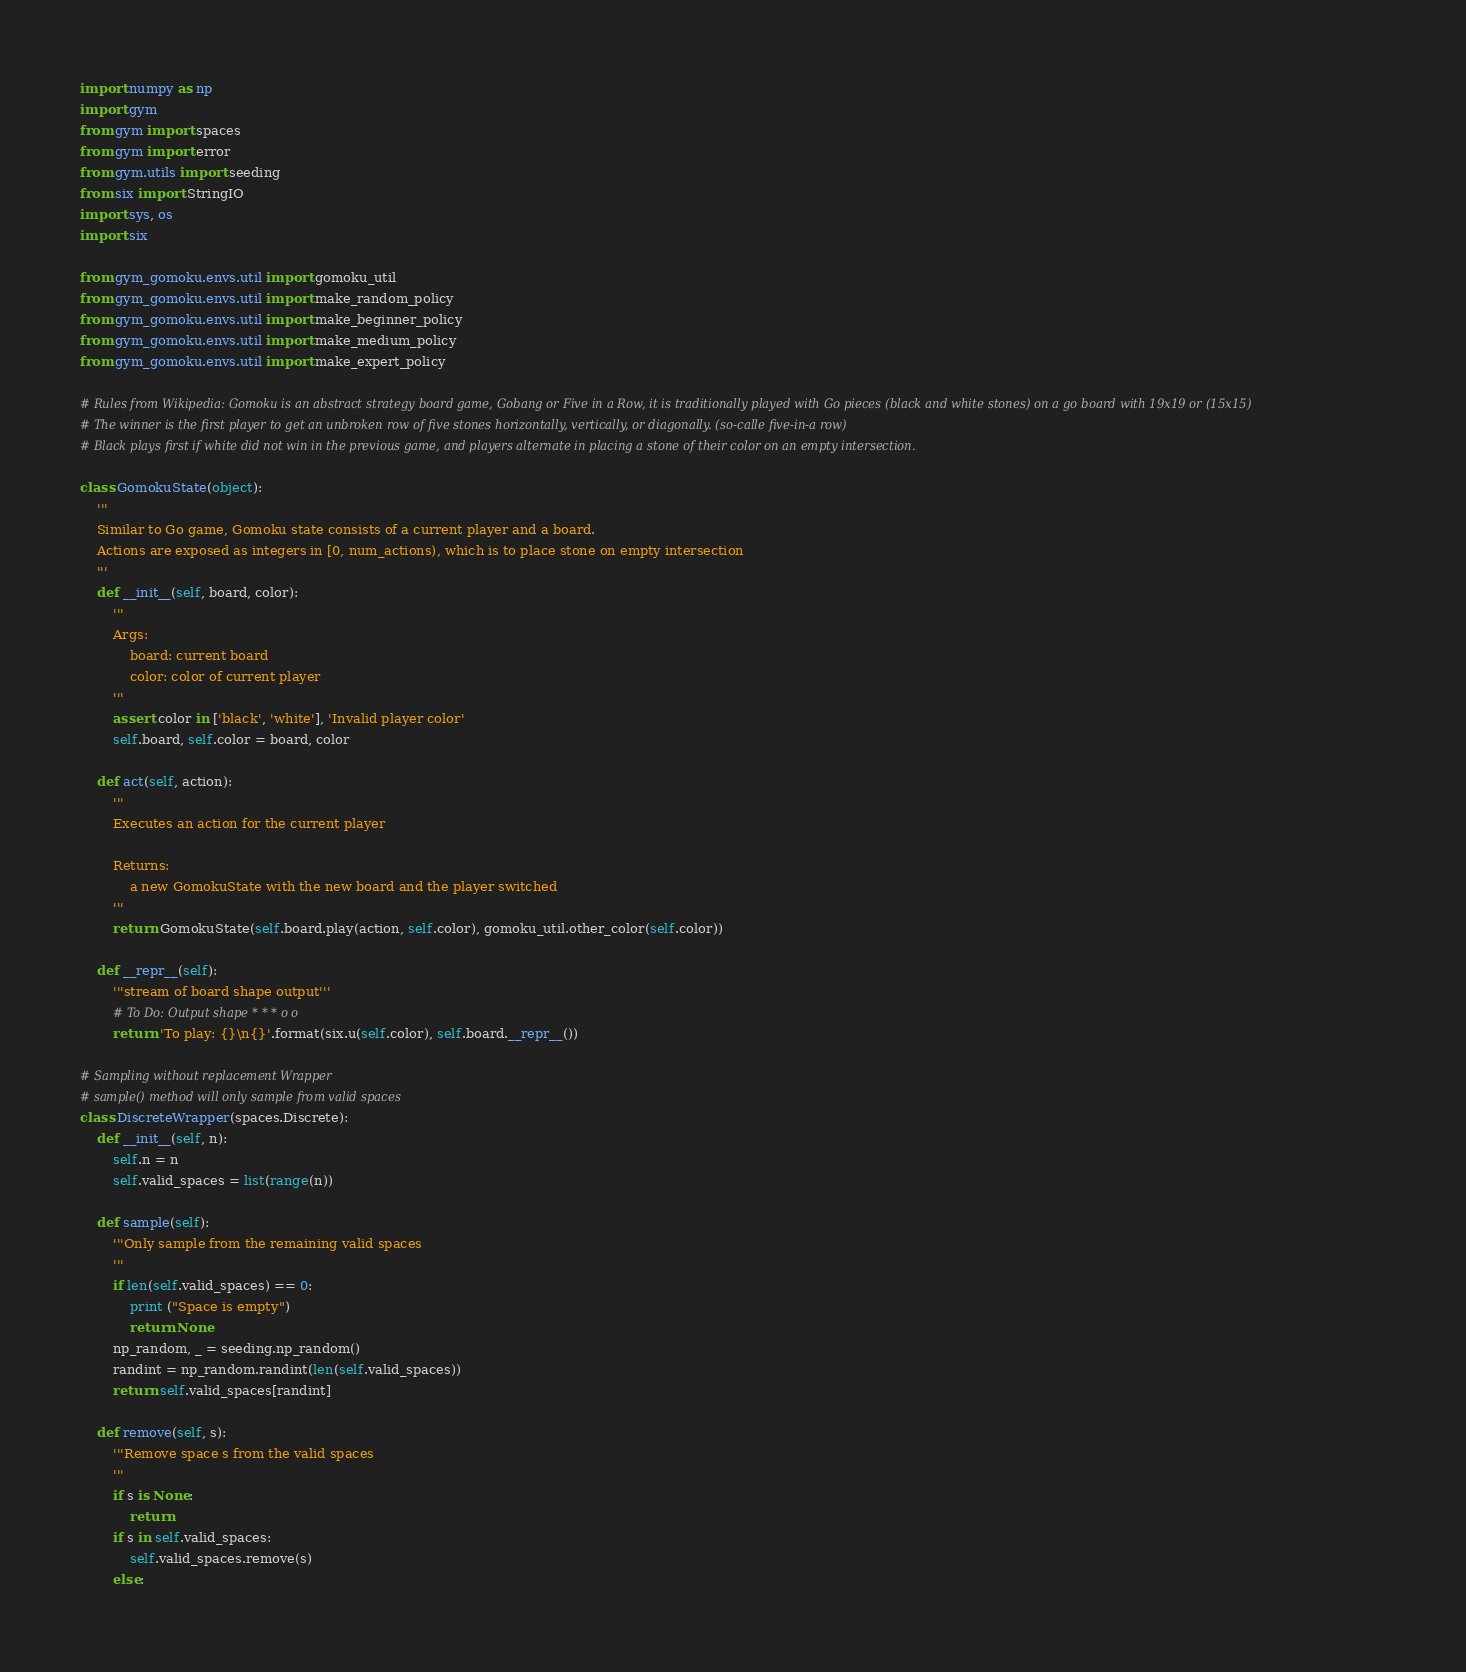<code> <loc_0><loc_0><loc_500><loc_500><_Python_>import numpy as np
import gym
from gym import spaces
from gym import error
from gym.utils import seeding
from six import StringIO
import sys, os
import six

from gym_gomoku.envs.util import gomoku_util
from gym_gomoku.envs.util import make_random_policy
from gym_gomoku.envs.util import make_beginner_policy
from gym_gomoku.envs.util import make_medium_policy
from gym_gomoku.envs.util import make_expert_policy

# Rules from Wikipedia: Gomoku is an abstract strategy board game, Gobang or Five in a Row, it is traditionally played with Go pieces (black and white stones) on a go board with 19x19 or (15x15) 
# The winner is the first player to get an unbroken row of five stones horizontally, vertically, or diagonally. (so-calle five-in-a row)
# Black plays first if white did not win in the previous game, and players alternate in placing a stone of their color on an empty intersection.

class GomokuState(object):
    '''
    Similar to Go game, Gomoku state consists of a current player and a board.
    Actions are exposed as integers in [0, num_actions), which is to place stone on empty intersection
    '''
    def __init__(self, board, color):
        '''
        Args:
            board: current board
            color: color of current player
        '''
        assert color in ['black', 'white'], 'Invalid player color'
        self.board, self.color = board, color
    
    def act(self, action):
        '''
        Executes an action for the current player
        
        Returns:
            a new GomokuState with the new board and the player switched
        '''
        return GomokuState(self.board.play(action, self.color), gomoku_util.other_color(self.color))
    
    def __repr__(self):
        '''stream of board shape output'''
        # To Do: Output shape * * * o o
        return 'To play: {}\n{}'.format(six.u(self.color), self.board.__repr__())

# Sampling without replacement Wrapper 
# sample() method will only sample from valid spaces
class DiscreteWrapper(spaces.Discrete):
    def __init__(self, n):
        self.n = n
        self.valid_spaces = list(range(n))
    
    def sample(self):
        '''Only sample from the remaining valid spaces
        '''
        if len(self.valid_spaces) == 0:
            print ("Space is empty")
            return None
        np_random, _ = seeding.np_random()
        randint = np_random.randint(len(self.valid_spaces))
        return self.valid_spaces[randint]
    
    def remove(self, s):
        '''Remove space s from the valid spaces
        '''
        if s is None:
            return
        if s in self.valid_spaces:
            self.valid_spaces.remove(s)
        else:</code> 